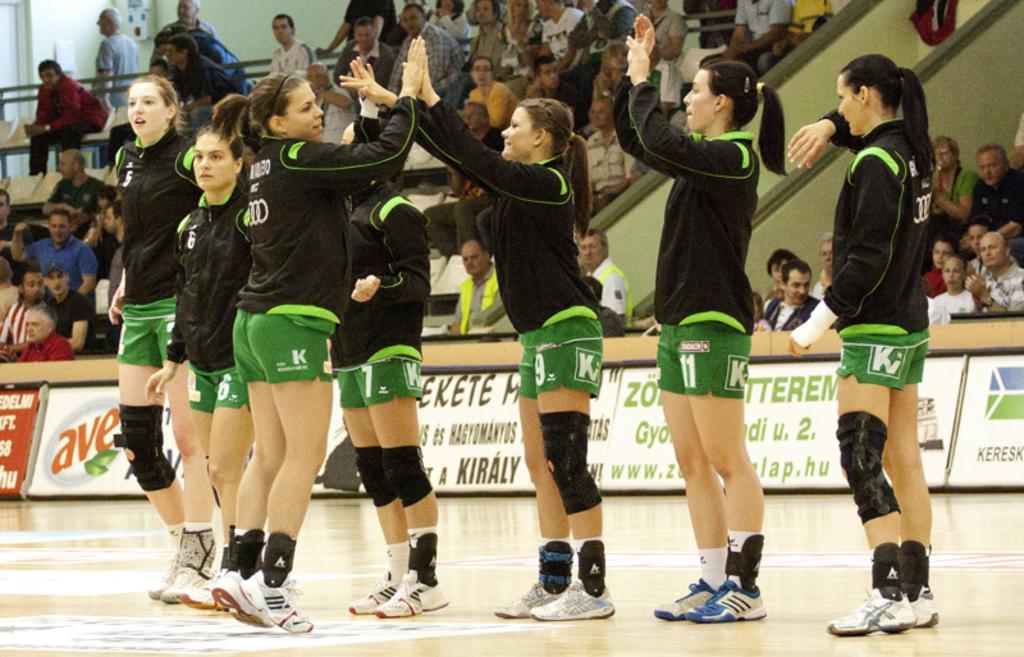Can you describe this image briefly? In the image there are few girls in black jersey and green shorts standing on the play field, in the back there are many audience sitting on chairs looking at the game. 